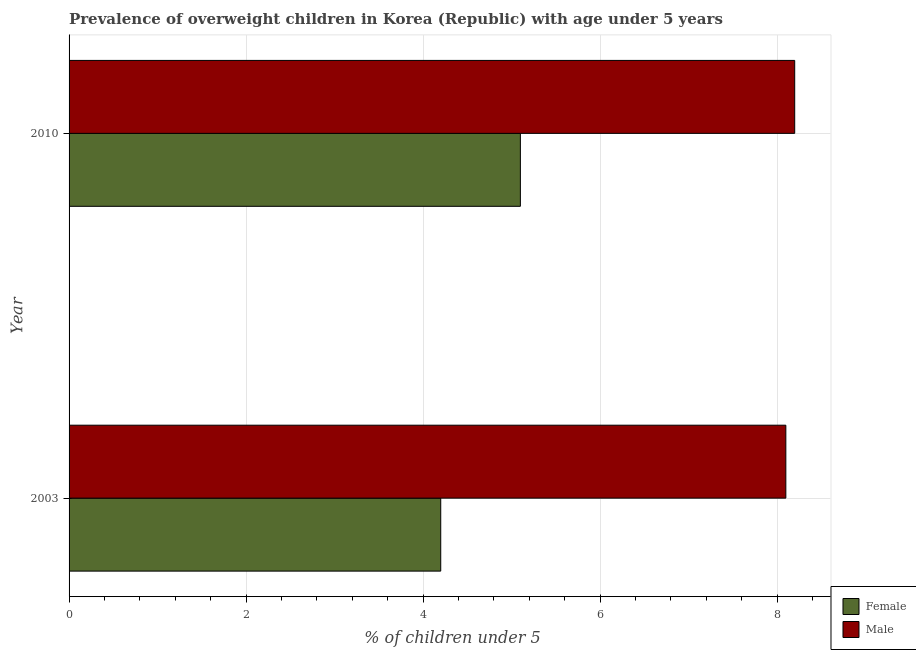How many different coloured bars are there?
Your answer should be very brief. 2. How many groups of bars are there?
Your response must be concise. 2. Are the number of bars per tick equal to the number of legend labels?
Provide a succinct answer. Yes. Are the number of bars on each tick of the Y-axis equal?
Offer a terse response. Yes. How many bars are there on the 1st tick from the bottom?
Provide a short and direct response. 2. In how many cases, is the number of bars for a given year not equal to the number of legend labels?
Provide a succinct answer. 0. What is the percentage of obese female children in 2003?
Your answer should be very brief. 4.2. Across all years, what is the maximum percentage of obese female children?
Your answer should be very brief. 5.1. Across all years, what is the minimum percentage of obese male children?
Ensure brevity in your answer.  8.1. What is the total percentage of obese male children in the graph?
Your answer should be very brief. 16.3. What is the difference between the percentage of obese female children in 2003 and that in 2010?
Offer a terse response. -0.9. What is the difference between the percentage of obese male children in 2010 and the percentage of obese female children in 2003?
Your answer should be very brief. 4. What is the average percentage of obese female children per year?
Offer a terse response. 4.65. In how many years, is the percentage of obese male children greater than 1.2000000000000002 %?
Provide a succinct answer. 2. Is the percentage of obese female children in 2003 less than that in 2010?
Your answer should be compact. Yes. In how many years, is the percentage of obese female children greater than the average percentage of obese female children taken over all years?
Give a very brief answer. 1. What does the 1st bar from the top in 2003 represents?
Your answer should be compact. Male. What is the difference between two consecutive major ticks on the X-axis?
Your answer should be compact. 2. Does the graph contain any zero values?
Your response must be concise. No. Where does the legend appear in the graph?
Provide a short and direct response. Bottom right. How many legend labels are there?
Provide a succinct answer. 2. How are the legend labels stacked?
Give a very brief answer. Vertical. What is the title of the graph?
Keep it short and to the point. Prevalence of overweight children in Korea (Republic) with age under 5 years. What is the label or title of the X-axis?
Give a very brief answer.  % of children under 5. What is the label or title of the Y-axis?
Make the answer very short. Year. What is the  % of children under 5 of Female in 2003?
Keep it short and to the point. 4.2. What is the  % of children under 5 in Male in 2003?
Ensure brevity in your answer.  8.1. What is the  % of children under 5 of Female in 2010?
Ensure brevity in your answer.  5.1. What is the  % of children under 5 in Male in 2010?
Provide a succinct answer. 8.2. Across all years, what is the maximum  % of children under 5 of Female?
Ensure brevity in your answer.  5.1. Across all years, what is the maximum  % of children under 5 in Male?
Ensure brevity in your answer.  8.2. Across all years, what is the minimum  % of children under 5 of Female?
Your answer should be very brief. 4.2. Across all years, what is the minimum  % of children under 5 of Male?
Keep it short and to the point. 8.1. What is the total  % of children under 5 in Female in the graph?
Give a very brief answer. 9.3. What is the difference between the  % of children under 5 in Male in 2003 and that in 2010?
Your response must be concise. -0.1. What is the difference between the  % of children under 5 of Female in 2003 and the  % of children under 5 of Male in 2010?
Your answer should be compact. -4. What is the average  % of children under 5 in Female per year?
Your answer should be very brief. 4.65. What is the average  % of children under 5 of Male per year?
Your response must be concise. 8.15. In the year 2003, what is the difference between the  % of children under 5 of Female and  % of children under 5 of Male?
Keep it short and to the point. -3.9. In the year 2010, what is the difference between the  % of children under 5 in Female and  % of children under 5 in Male?
Your response must be concise. -3.1. What is the ratio of the  % of children under 5 of Female in 2003 to that in 2010?
Keep it short and to the point. 0.82. What is the ratio of the  % of children under 5 of Male in 2003 to that in 2010?
Your response must be concise. 0.99. What is the difference between the highest and the second highest  % of children under 5 in Female?
Offer a terse response. 0.9. What is the difference between the highest and the lowest  % of children under 5 in Female?
Ensure brevity in your answer.  0.9. 